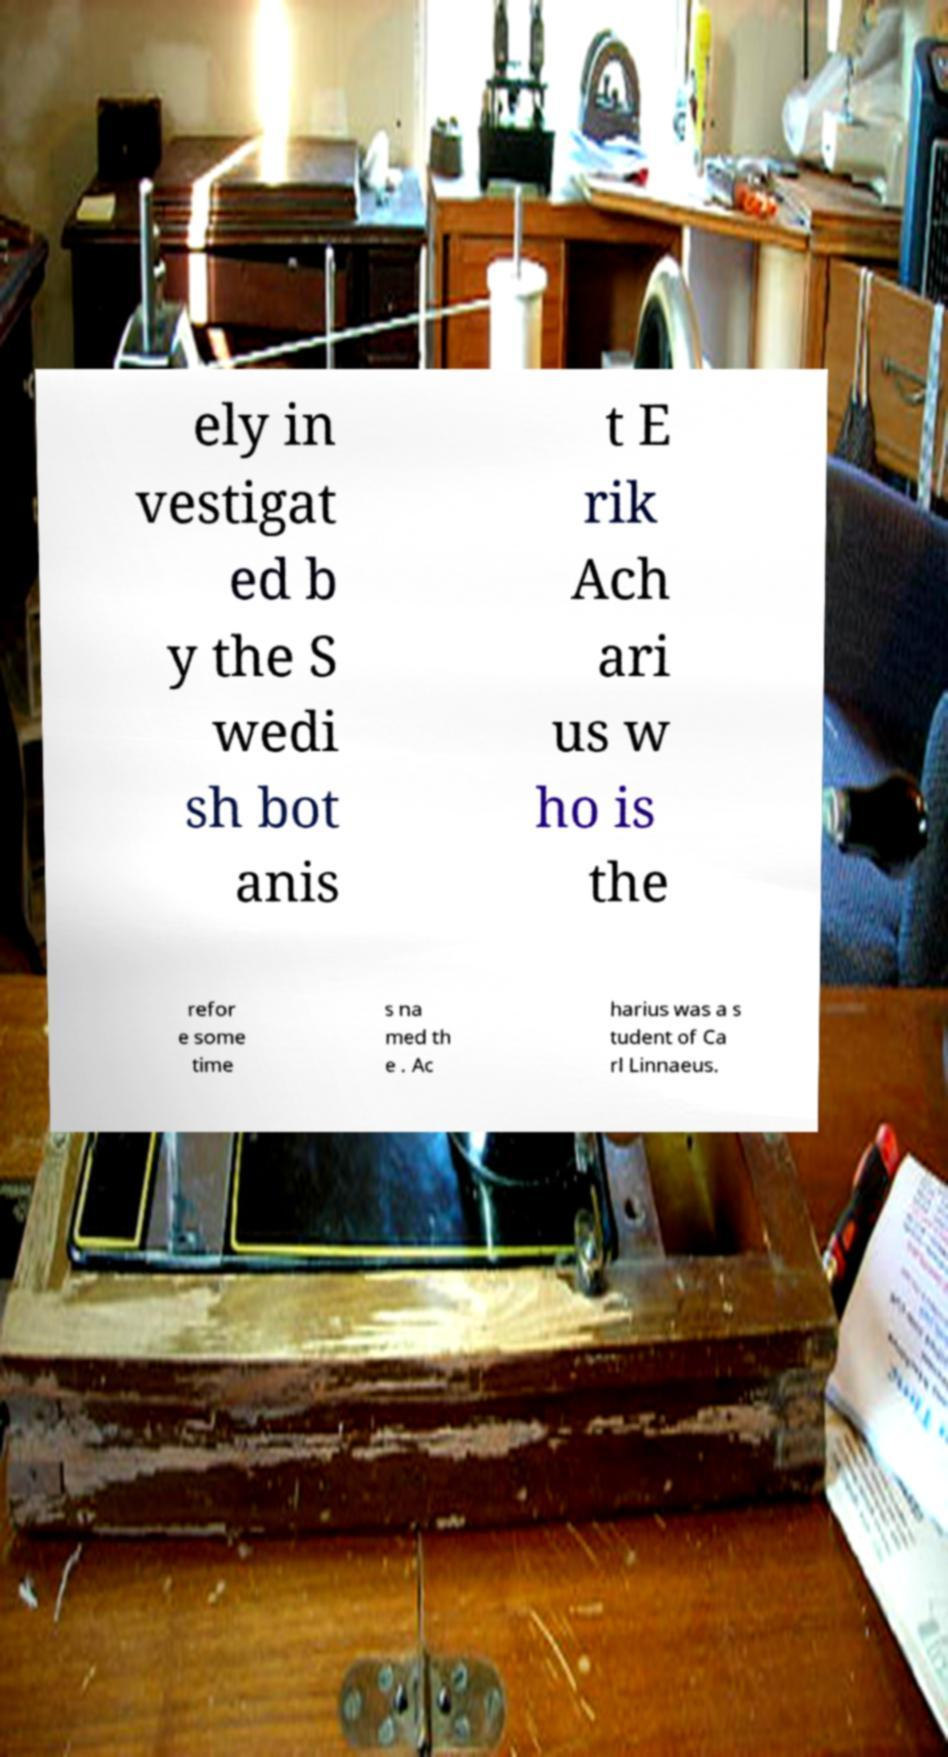There's text embedded in this image that I need extracted. Can you transcribe it verbatim? ely in vestigat ed b y the S wedi sh bot anis t E rik Ach ari us w ho is the refor e some time s na med th e . Ac harius was a s tudent of Ca rl Linnaeus. 